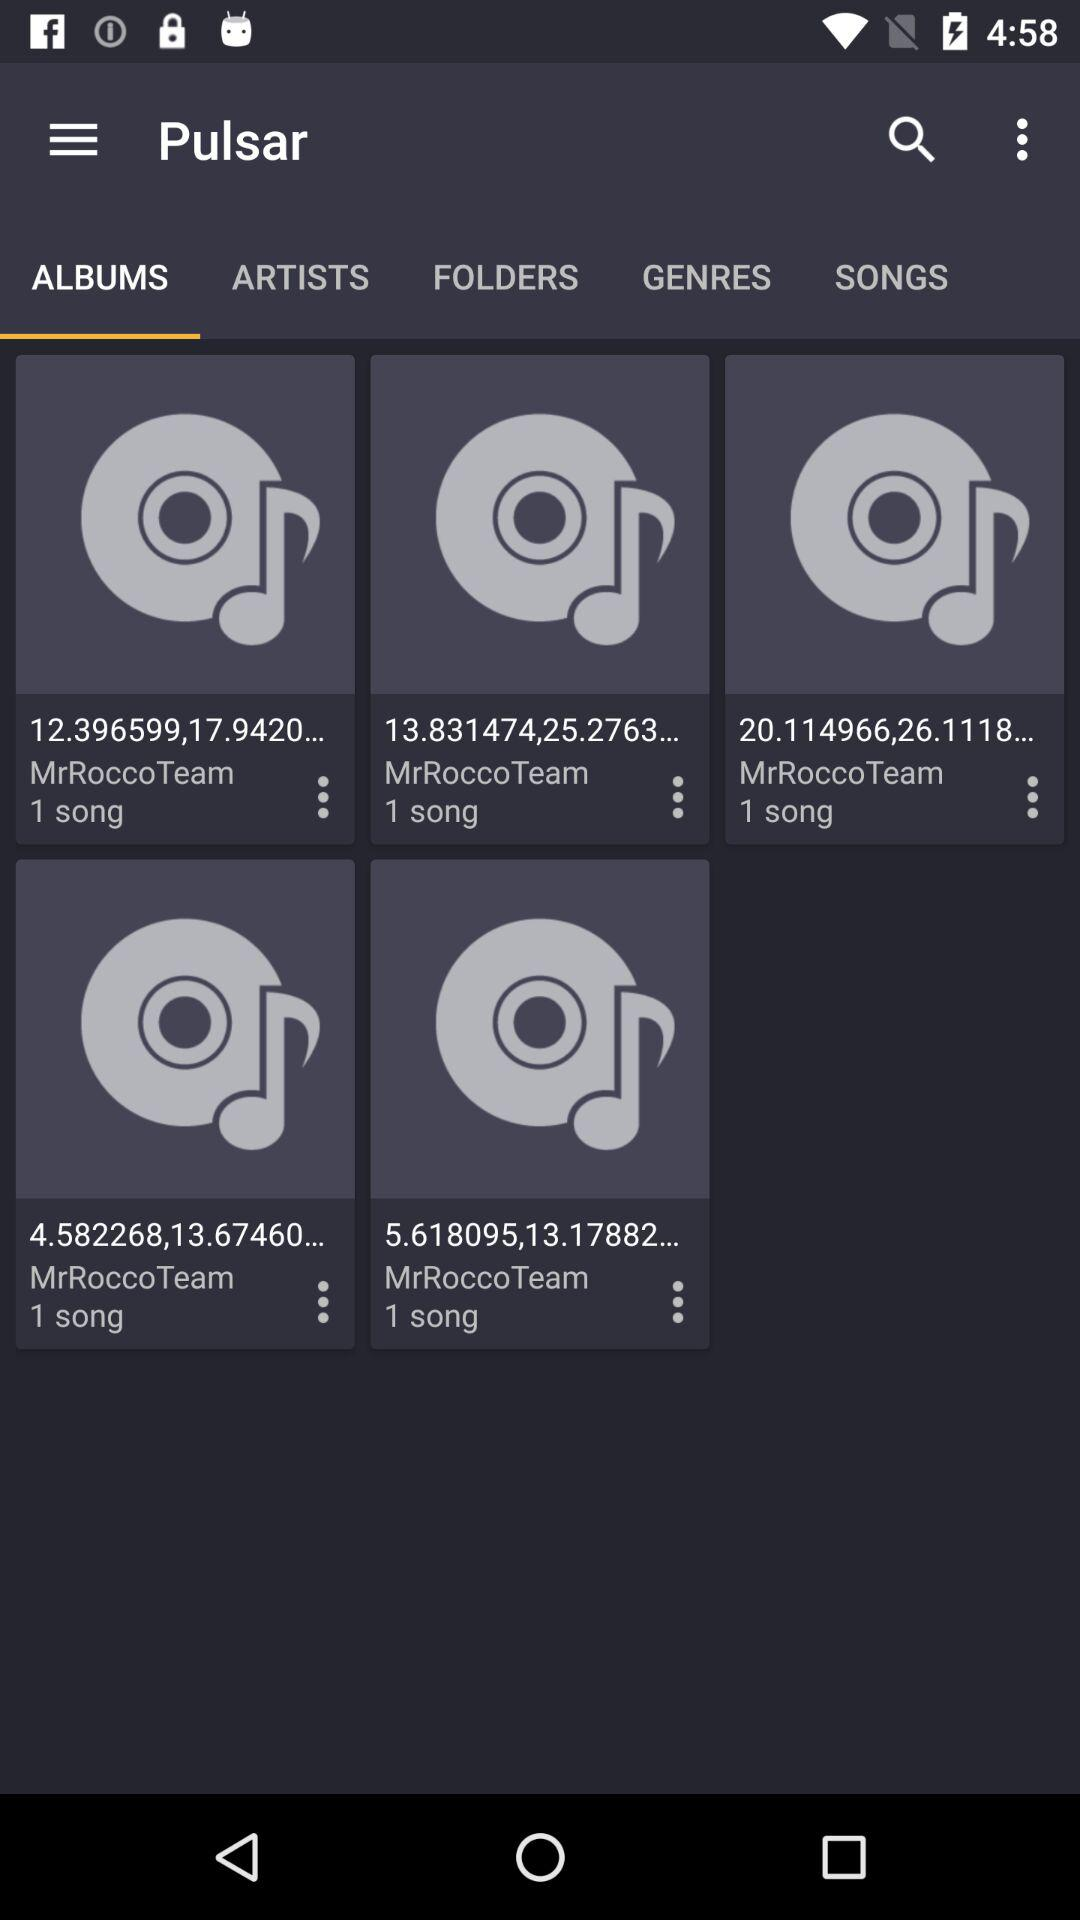Which is the selected tab? The selected tab is "ALBUMS". 